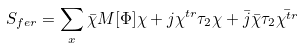<formula> <loc_0><loc_0><loc_500><loc_500>S _ { f e r } = \sum _ { x } \bar { \chi } M [ \Phi ] \chi + j \chi ^ { t r } \tau _ { 2 } \chi + \bar { j } \bar { \chi } \tau _ { 2 } \bar { \chi ^ { t r } }</formula> 